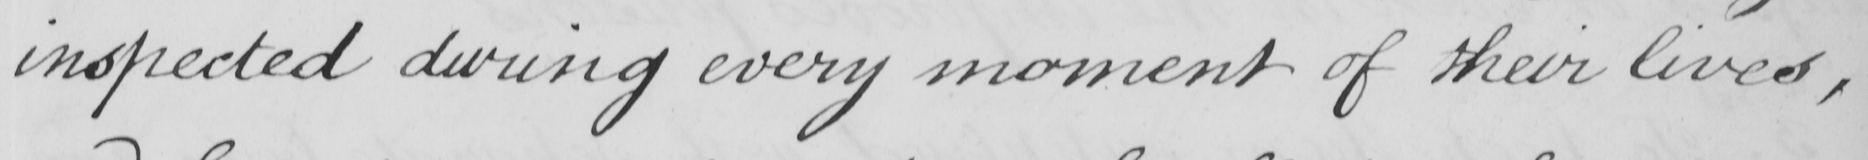Can you read and transcribe this handwriting? inspected during every moment of their lives , 